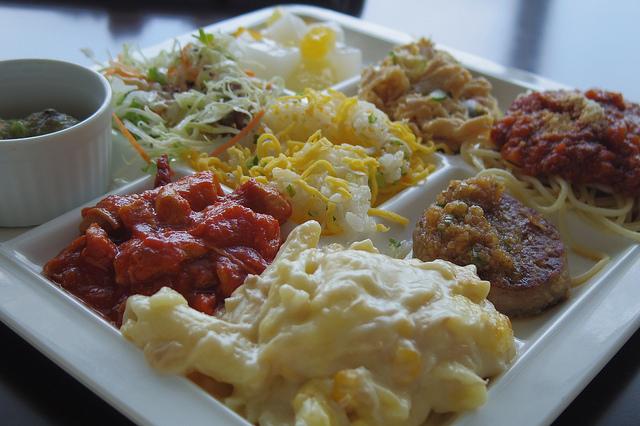Do you see any slices of bread?
Quick response, please. No. How many foods are seen?
Keep it brief. 9. Is there any pineapple on the plate??
Write a very short answer. No. Is there anything to drink?
Concise answer only. No. 